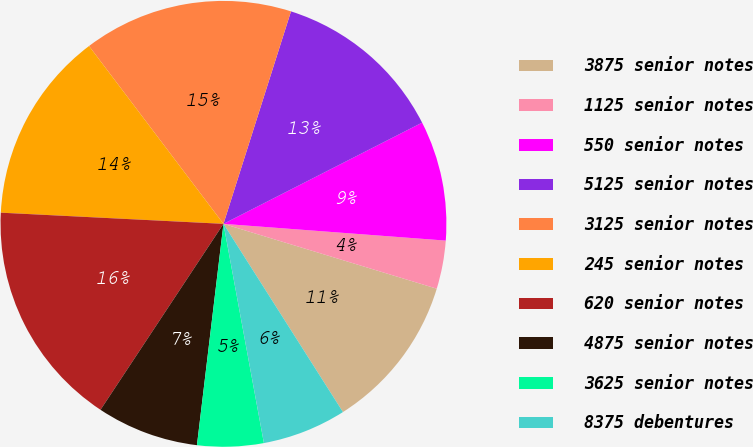<chart> <loc_0><loc_0><loc_500><loc_500><pie_chart><fcel>3875 senior notes<fcel>1125 senior notes<fcel>550 senior notes<fcel>5125 senior notes<fcel>3125 senior notes<fcel>245 senior notes<fcel>620 senior notes<fcel>4875 senior notes<fcel>3625 senior notes<fcel>8375 debentures<nl><fcel>11.3%<fcel>3.5%<fcel>8.7%<fcel>12.6%<fcel>15.2%<fcel>13.9%<fcel>16.5%<fcel>7.4%<fcel>4.8%<fcel>6.1%<nl></chart> 